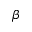<formula> <loc_0><loc_0><loc_500><loc_500>\beta</formula> 